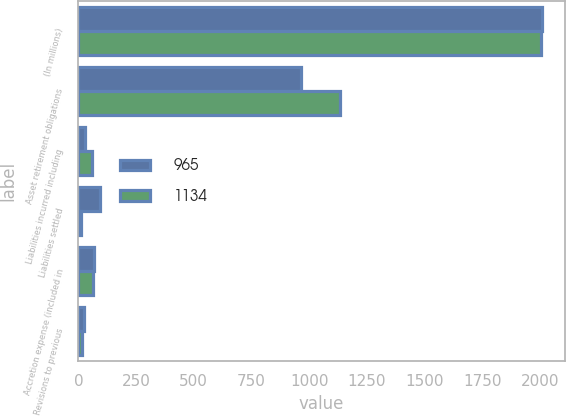Convert chart. <chart><loc_0><loc_0><loc_500><loc_500><stacked_bar_chart><ecel><fcel>(In millions)<fcel>Asset retirement obligations<fcel>Liabilities incurred including<fcel>Liabilities settled<fcel>Accretion expense (included in<fcel>Revisions to previous<nl><fcel>965<fcel>2008<fcel>965<fcel>30<fcel>94<fcel>66<fcel>24<nl><fcel>1134<fcel>2007<fcel>1134<fcel>60<fcel>10<fcel>61<fcel>17<nl></chart> 